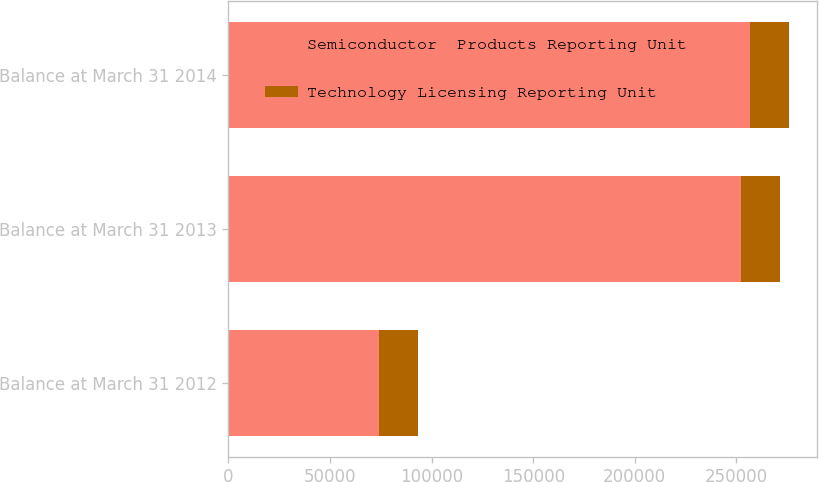Convert chart to OTSL. <chart><loc_0><loc_0><loc_500><loc_500><stacked_bar_chart><ecel><fcel>Balance at March 31 2012<fcel>Balance at March 31 2013<fcel>Balance at March 31 2014<nl><fcel>Semiconductor  Products Reporting Unit<fcel>74313<fcel>252148<fcel>256897<nl><fcel>Technology Licensing Reporting Unit<fcel>19200<fcel>19200<fcel>19200<nl></chart> 